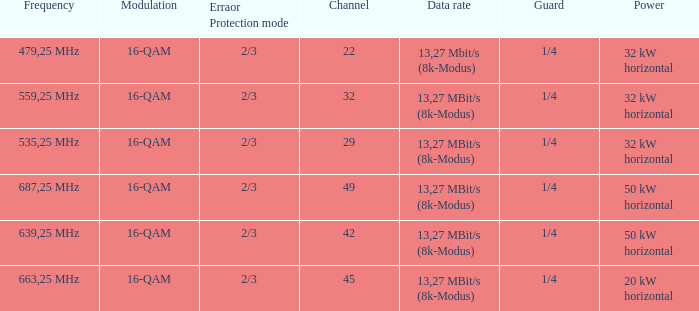On channel 32, when the power is 32 kW horizontal, what is the modulation? 16-QAM. 